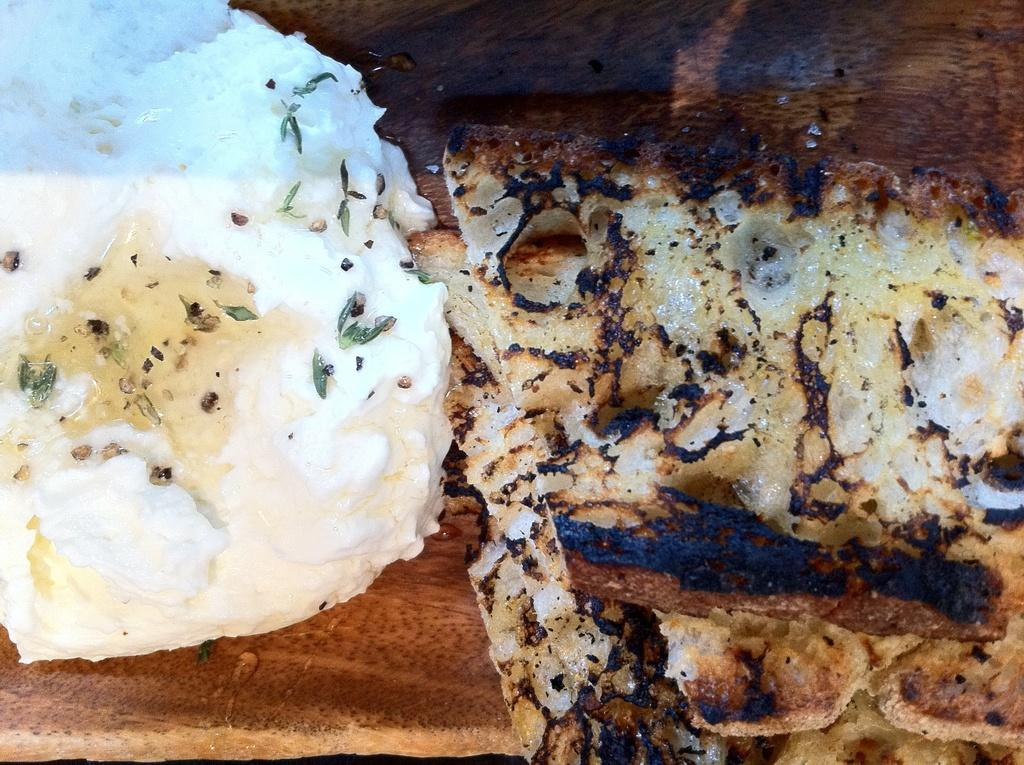What types of items can be seen in the image? There are food items in the image. Where are the food items placed? The food items are placed on a wooden platform. How many clams are visible on the wooden platform in the image? There is no mention of clams in the provided facts, so we cannot determine if any are present in the image. 